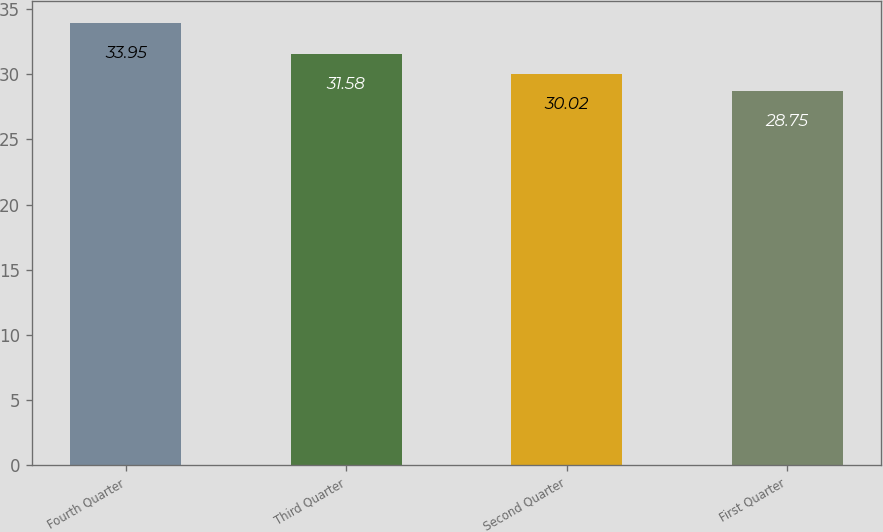Convert chart to OTSL. <chart><loc_0><loc_0><loc_500><loc_500><bar_chart><fcel>Fourth Quarter<fcel>Third Quarter<fcel>Second Quarter<fcel>First Quarter<nl><fcel>33.95<fcel>31.58<fcel>30.02<fcel>28.75<nl></chart> 